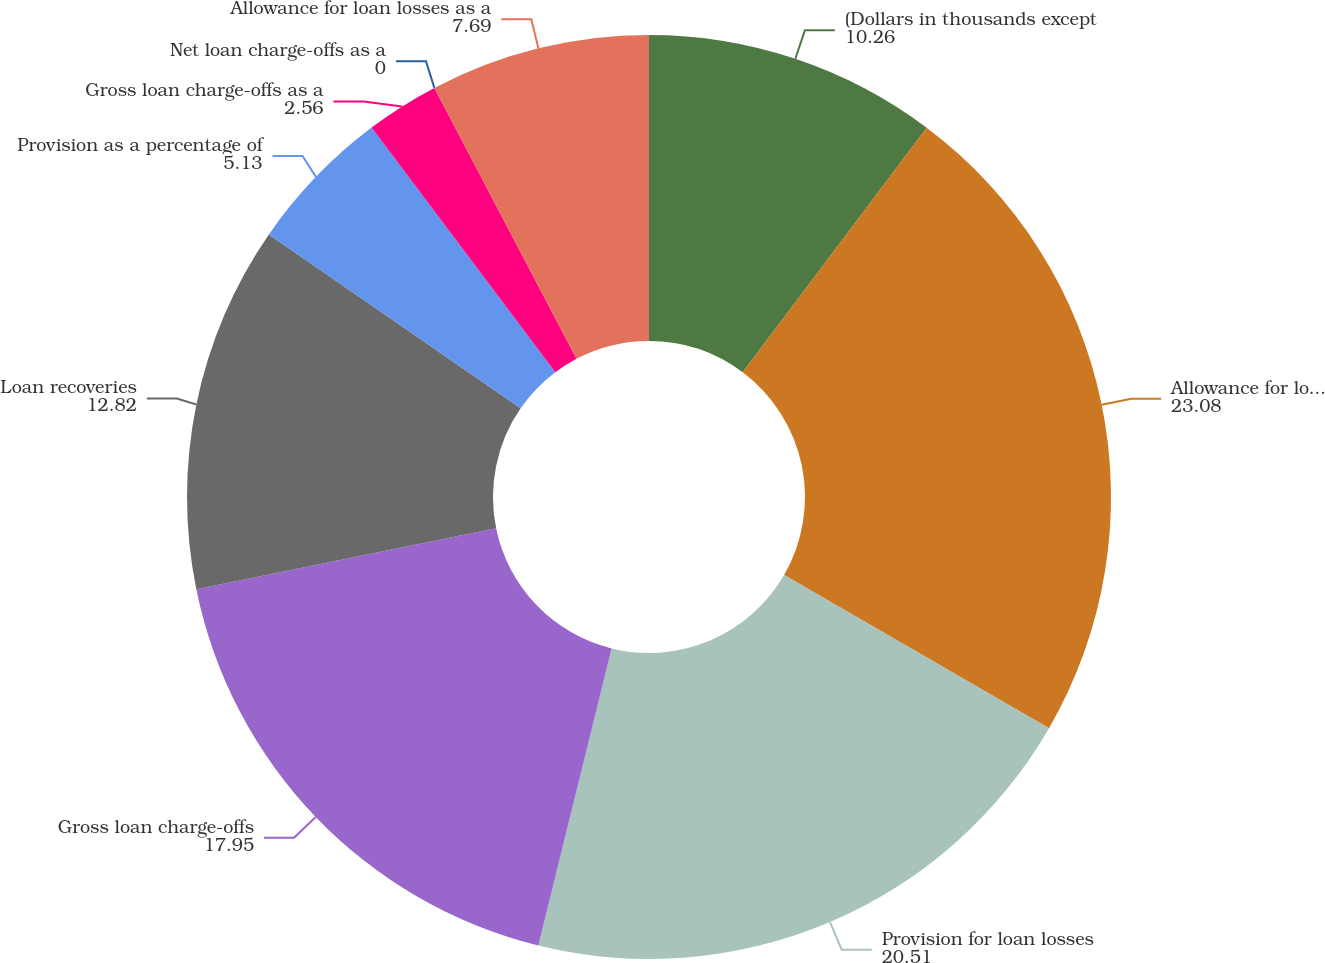Convert chart to OTSL. <chart><loc_0><loc_0><loc_500><loc_500><pie_chart><fcel>(Dollars in thousands except<fcel>Allowance for loan losses<fcel>Provision for loan losses<fcel>Gross loan charge-offs<fcel>Loan recoveries<fcel>Provision as a percentage of<fcel>Gross loan charge-offs as a<fcel>Net loan charge-offs as a<fcel>Allowance for loan losses as a<nl><fcel>10.26%<fcel>23.08%<fcel>20.51%<fcel>17.95%<fcel>12.82%<fcel>5.13%<fcel>2.56%<fcel>0.0%<fcel>7.69%<nl></chart> 